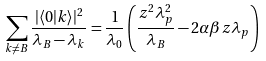<formula> <loc_0><loc_0><loc_500><loc_500>\sum _ { k \neq B } \frac { | \langle 0 | k \rangle | ^ { 2 } } { \lambda _ { B } - \lambda _ { k } } = \frac { 1 } { \lambda _ { 0 } } \left ( \frac { z ^ { 2 } \lambda _ { p } ^ { 2 } } { \lambda _ { B } } - 2 \alpha \beta z \lambda _ { p } \right )</formula> 